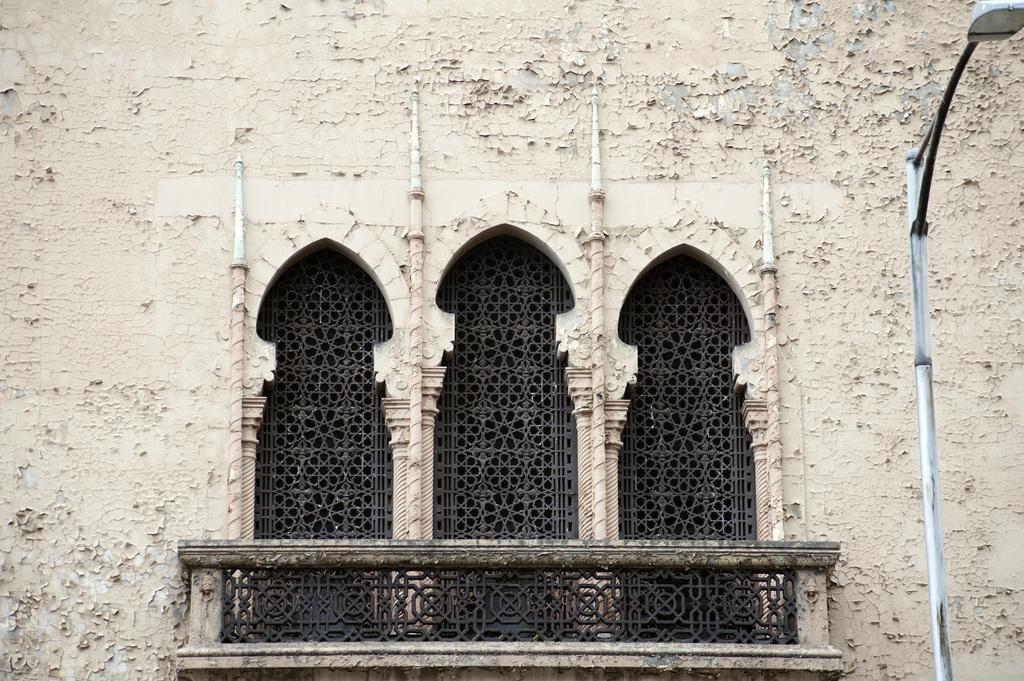What is the main structure in the picture? There is a castle in the picture. What features can be seen on the castle? The castle has windows and a hand-grill. What is located on the right side of the picture? There is a pole with a light on the right side of the picture. Can you tell me where the doctor's office is located in the picture? There is no doctor's office present in the picture; it features a castle with windows and a hand-grill, as well as a pole with a light on the right side. 